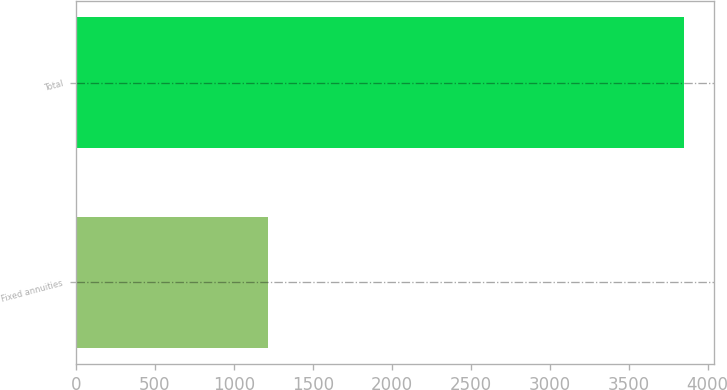Convert chart. <chart><loc_0><loc_0><loc_500><loc_500><bar_chart><fcel>Fixed annuities<fcel>Total<nl><fcel>1219<fcel>3848<nl></chart> 